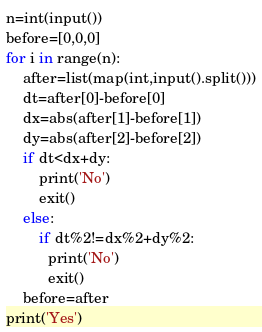Convert code to text. <code><loc_0><loc_0><loc_500><loc_500><_Python_>n=int(input())
before=[0,0,0]
for i in range(n):
    after=list(map(int,input().split()))
    dt=after[0]-before[0]
    dx=abs(after[1]-before[1])
    dy=abs(after[2]-before[2])
    if dt<dx+dy:
        print('No')
        exit()
    else:
        if dt%2!=dx%2+dy%2:
          print('No')
          exit()        
    before=after
print('Yes')</code> 